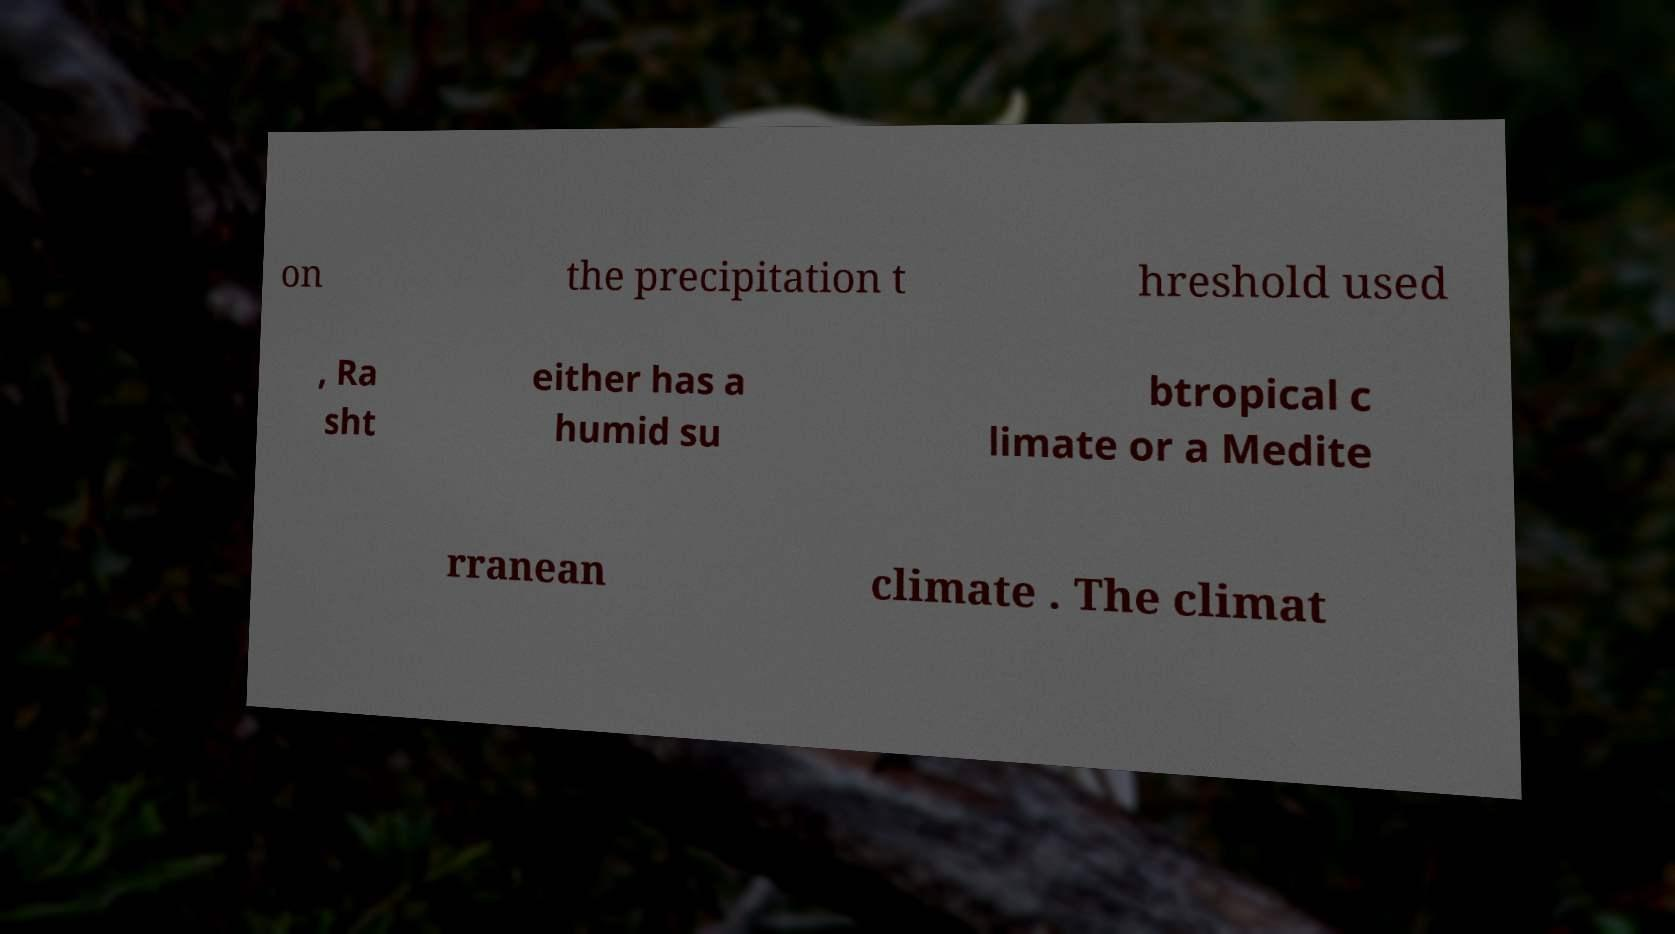Could you extract and type out the text from this image? on the precipitation t hreshold used , Ra sht either has a humid su btropical c limate or a Medite rranean climate . The climat 